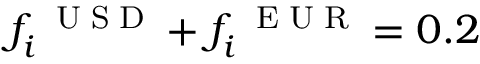Convert formula to latex. <formula><loc_0><loc_0><loc_500><loc_500>f _ { i } ^ { U S D } + f _ { i } ^ { E U R } = 0 . 2</formula> 